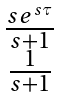Convert formula to latex. <formula><loc_0><loc_0><loc_500><loc_500>\begin{matrix} \frac { s e ^ { s \tau } } { s + 1 } \\ \frac { 1 } { s + 1 } \end{matrix}</formula> 